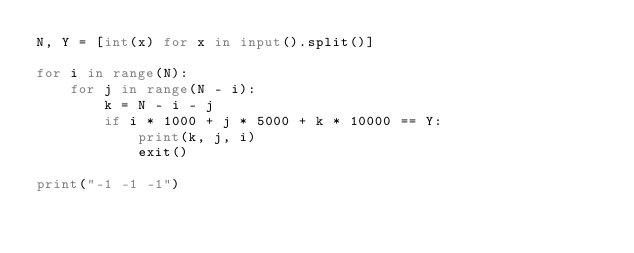<code> <loc_0><loc_0><loc_500><loc_500><_Python_>N, Y = [int(x) for x in input().split()]

for i in range(N):
    for j in range(N - i):
        k = N - i - j
        if i * 1000 + j * 5000 + k * 10000 == Y:
            print(k, j, i)
            exit()

print("-1 -1 -1")
</code> 